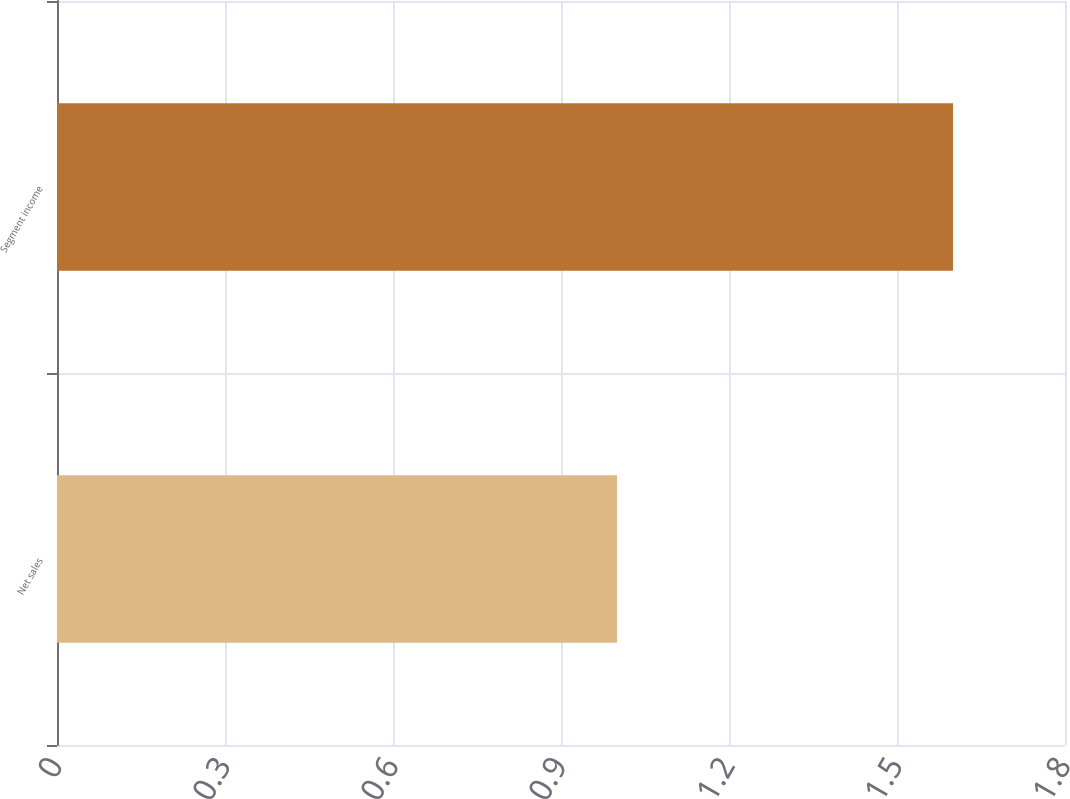Convert chart. <chart><loc_0><loc_0><loc_500><loc_500><bar_chart><fcel>Net sales<fcel>Segment income<nl><fcel>1<fcel>1.6<nl></chart> 